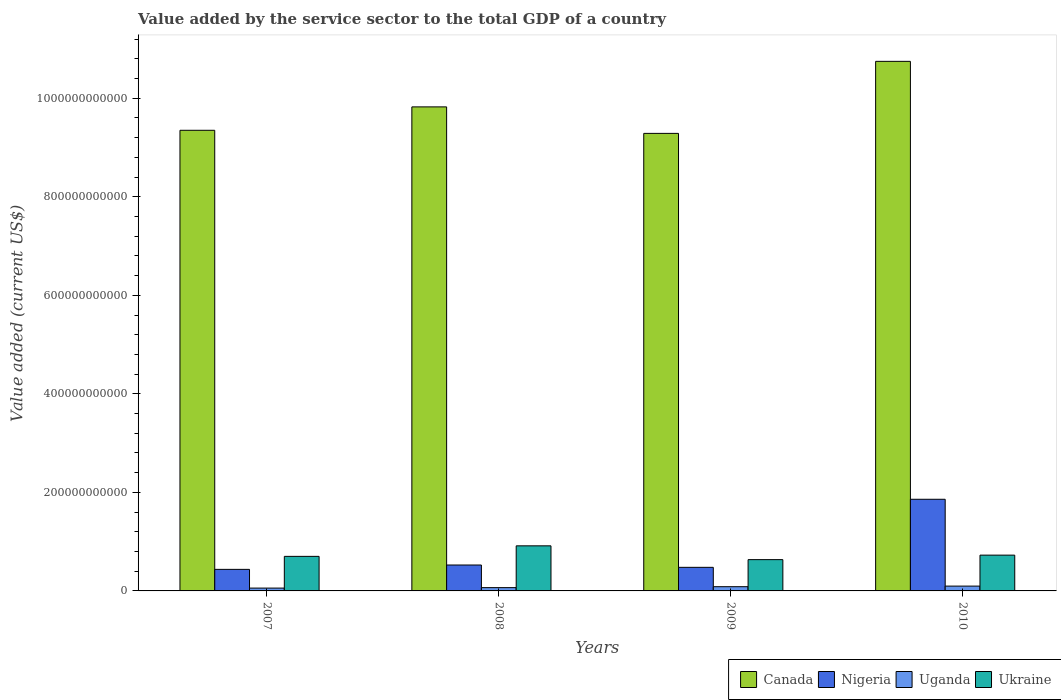What is the label of the 1st group of bars from the left?
Make the answer very short. 2007. What is the value added by the service sector to the total GDP in Ukraine in 2010?
Give a very brief answer. 7.26e+1. Across all years, what is the maximum value added by the service sector to the total GDP in Nigeria?
Offer a very short reply. 1.86e+11. Across all years, what is the minimum value added by the service sector to the total GDP in Ukraine?
Your response must be concise. 6.35e+1. In which year was the value added by the service sector to the total GDP in Ukraine maximum?
Your answer should be compact. 2008. In which year was the value added by the service sector to the total GDP in Ukraine minimum?
Keep it short and to the point. 2009. What is the total value added by the service sector to the total GDP in Uganda in the graph?
Your response must be concise. 3.08e+1. What is the difference between the value added by the service sector to the total GDP in Canada in 2007 and that in 2010?
Keep it short and to the point. -1.40e+11. What is the difference between the value added by the service sector to the total GDP in Ukraine in 2010 and the value added by the service sector to the total GDP in Uganda in 2009?
Your answer should be very brief. 6.41e+1. What is the average value added by the service sector to the total GDP in Canada per year?
Ensure brevity in your answer.  9.80e+11. In the year 2008, what is the difference between the value added by the service sector to the total GDP in Canada and value added by the service sector to the total GDP in Ukraine?
Offer a terse response. 8.91e+11. In how many years, is the value added by the service sector to the total GDP in Uganda greater than 440000000000 US$?
Offer a very short reply. 0. What is the ratio of the value added by the service sector to the total GDP in Uganda in 2007 to that in 2010?
Give a very brief answer. 0.59. Is the value added by the service sector to the total GDP in Ukraine in 2008 less than that in 2010?
Your answer should be very brief. No. Is the difference between the value added by the service sector to the total GDP in Canada in 2008 and 2009 greater than the difference between the value added by the service sector to the total GDP in Ukraine in 2008 and 2009?
Your response must be concise. Yes. What is the difference between the highest and the second highest value added by the service sector to the total GDP in Ukraine?
Offer a very short reply. 1.89e+1. What is the difference between the highest and the lowest value added by the service sector to the total GDP in Canada?
Your response must be concise. 1.46e+11. Is the sum of the value added by the service sector to the total GDP in Nigeria in 2007 and 2009 greater than the maximum value added by the service sector to the total GDP in Ukraine across all years?
Provide a succinct answer. Yes. Is it the case that in every year, the sum of the value added by the service sector to the total GDP in Nigeria and value added by the service sector to the total GDP in Canada is greater than the sum of value added by the service sector to the total GDP in Uganda and value added by the service sector to the total GDP in Ukraine?
Your answer should be compact. Yes. What does the 2nd bar from the left in 2010 represents?
Ensure brevity in your answer.  Nigeria. What does the 1st bar from the right in 2007 represents?
Make the answer very short. Ukraine. Is it the case that in every year, the sum of the value added by the service sector to the total GDP in Canada and value added by the service sector to the total GDP in Uganda is greater than the value added by the service sector to the total GDP in Nigeria?
Your answer should be compact. Yes. How many years are there in the graph?
Keep it short and to the point. 4. What is the difference between two consecutive major ticks on the Y-axis?
Provide a short and direct response. 2.00e+11. Does the graph contain any zero values?
Provide a short and direct response. No. Does the graph contain grids?
Your answer should be very brief. No. Where does the legend appear in the graph?
Give a very brief answer. Bottom right. What is the title of the graph?
Your answer should be compact. Value added by the service sector to the total GDP of a country. What is the label or title of the Y-axis?
Your response must be concise. Value added (current US$). What is the Value added (current US$) in Canada in 2007?
Give a very brief answer. 9.35e+11. What is the Value added (current US$) of Nigeria in 2007?
Your response must be concise. 4.37e+1. What is the Value added (current US$) in Uganda in 2007?
Offer a very short reply. 5.77e+09. What is the Value added (current US$) in Ukraine in 2007?
Keep it short and to the point. 7.01e+1. What is the Value added (current US$) of Canada in 2008?
Offer a very short reply. 9.82e+11. What is the Value added (current US$) in Nigeria in 2008?
Your answer should be compact. 5.26e+1. What is the Value added (current US$) in Uganda in 2008?
Ensure brevity in your answer.  6.68e+09. What is the Value added (current US$) of Ukraine in 2008?
Your answer should be compact. 9.15e+1. What is the Value added (current US$) in Canada in 2009?
Offer a very short reply. 9.29e+11. What is the Value added (current US$) in Nigeria in 2009?
Offer a very short reply. 4.79e+1. What is the Value added (current US$) in Uganda in 2009?
Your answer should be very brief. 8.58e+09. What is the Value added (current US$) of Ukraine in 2009?
Your answer should be very brief. 6.35e+1. What is the Value added (current US$) of Canada in 2010?
Your answer should be very brief. 1.07e+12. What is the Value added (current US$) in Nigeria in 2010?
Your answer should be compact. 1.86e+11. What is the Value added (current US$) of Uganda in 2010?
Your response must be concise. 9.79e+09. What is the Value added (current US$) of Ukraine in 2010?
Offer a very short reply. 7.26e+1. Across all years, what is the maximum Value added (current US$) in Canada?
Your response must be concise. 1.07e+12. Across all years, what is the maximum Value added (current US$) of Nigeria?
Your answer should be very brief. 1.86e+11. Across all years, what is the maximum Value added (current US$) in Uganda?
Offer a terse response. 9.79e+09. Across all years, what is the maximum Value added (current US$) in Ukraine?
Make the answer very short. 9.15e+1. Across all years, what is the minimum Value added (current US$) in Canada?
Keep it short and to the point. 9.29e+11. Across all years, what is the minimum Value added (current US$) in Nigeria?
Offer a very short reply. 4.37e+1. Across all years, what is the minimum Value added (current US$) of Uganda?
Offer a terse response. 5.77e+09. Across all years, what is the minimum Value added (current US$) of Ukraine?
Give a very brief answer. 6.35e+1. What is the total Value added (current US$) in Canada in the graph?
Provide a succinct answer. 3.92e+12. What is the total Value added (current US$) of Nigeria in the graph?
Provide a short and direct response. 3.30e+11. What is the total Value added (current US$) in Uganda in the graph?
Offer a very short reply. 3.08e+1. What is the total Value added (current US$) in Ukraine in the graph?
Your answer should be very brief. 2.98e+11. What is the difference between the Value added (current US$) of Canada in 2007 and that in 2008?
Provide a succinct answer. -4.75e+1. What is the difference between the Value added (current US$) of Nigeria in 2007 and that in 2008?
Provide a short and direct response. -8.87e+09. What is the difference between the Value added (current US$) of Uganda in 2007 and that in 2008?
Offer a terse response. -9.09e+08. What is the difference between the Value added (current US$) of Ukraine in 2007 and that in 2008?
Your answer should be very brief. -2.14e+1. What is the difference between the Value added (current US$) in Canada in 2007 and that in 2009?
Make the answer very short. 6.28e+09. What is the difference between the Value added (current US$) in Nigeria in 2007 and that in 2009?
Your response must be concise. -4.13e+09. What is the difference between the Value added (current US$) of Uganda in 2007 and that in 2009?
Offer a terse response. -2.82e+09. What is the difference between the Value added (current US$) in Ukraine in 2007 and that in 2009?
Provide a succinct answer. 6.63e+09. What is the difference between the Value added (current US$) in Canada in 2007 and that in 2010?
Make the answer very short. -1.40e+11. What is the difference between the Value added (current US$) in Nigeria in 2007 and that in 2010?
Ensure brevity in your answer.  -1.42e+11. What is the difference between the Value added (current US$) of Uganda in 2007 and that in 2010?
Offer a very short reply. -4.02e+09. What is the difference between the Value added (current US$) in Ukraine in 2007 and that in 2010?
Give a very brief answer. -2.49e+09. What is the difference between the Value added (current US$) in Canada in 2008 and that in 2009?
Make the answer very short. 5.38e+1. What is the difference between the Value added (current US$) in Nigeria in 2008 and that in 2009?
Ensure brevity in your answer.  4.74e+09. What is the difference between the Value added (current US$) in Uganda in 2008 and that in 2009?
Offer a very short reply. -1.91e+09. What is the difference between the Value added (current US$) of Ukraine in 2008 and that in 2009?
Your response must be concise. 2.80e+1. What is the difference between the Value added (current US$) in Canada in 2008 and that in 2010?
Provide a short and direct response. -9.24e+1. What is the difference between the Value added (current US$) of Nigeria in 2008 and that in 2010?
Provide a short and direct response. -1.33e+11. What is the difference between the Value added (current US$) in Uganda in 2008 and that in 2010?
Give a very brief answer. -3.11e+09. What is the difference between the Value added (current US$) of Ukraine in 2008 and that in 2010?
Keep it short and to the point. 1.89e+1. What is the difference between the Value added (current US$) in Canada in 2009 and that in 2010?
Give a very brief answer. -1.46e+11. What is the difference between the Value added (current US$) of Nigeria in 2009 and that in 2010?
Provide a short and direct response. -1.38e+11. What is the difference between the Value added (current US$) of Uganda in 2009 and that in 2010?
Offer a terse response. -1.20e+09. What is the difference between the Value added (current US$) in Ukraine in 2009 and that in 2010?
Provide a succinct answer. -9.12e+09. What is the difference between the Value added (current US$) in Canada in 2007 and the Value added (current US$) in Nigeria in 2008?
Your answer should be very brief. 8.82e+11. What is the difference between the Value added (current US$) in Canada in 2007 and the Value added (current US$) in Uganda in 2008?
Your answer should be very brief. 9.28e+11. What is the difference between the Value added (current US$) in Canada in 2007 and the Value added (current US$) in Ukraine in 2008?
Your answer should be compact. 8.43e+11. What is the difference between the Value added (current US$) in Nigeria in 2007 and the Value added (current US$) in Uganda in 2008?
Offer a terse response. 3.71e+1. What is the difference between the Value added (current US$) in Nigeria in 2007 and the Value added (current US$) in Ukraine in 2008?
Keep it short and to the point. -4.78e+1. What is the difference between the Value added (current US$) of Uganda in 2007 and the Value added (current US$) of Ukraine in 2008?
Offer a terse response. -8.57e+1. What is the difference between the Value added (current US$) of Canada in 2007 and the Value added (current US$) of Nigeria in 2009?
Provide a short and direct response. 8.87e+11. What is the difference between the Value added (current US$) of Canada in 2007 and the Value added (current US$) of Uganda in 2009?
Your answer should be very brief. 9.26e+11. What is the difference between the Value added (current US$) of Canada in 2007 and the Value added (current US$) of Ukraine in 2009?
Offer a very short reply. 8.71e+11. What is the difference between the Value added (current US$) in Nigeria in 2007 and the Value added (current US$) in Uganda in 2009?
Ensure brevity in your answer.  3.51e+1. What is the difference between the Value added (current US$) of Nigeria in 2007 and the Value added (current US$) of Ukraine in 2009?
Ensure brevity in your answer.  -1.98e+1. What is the difference between the Value added (current US$) in Uganda in 2007 and the Value added (current US$) in Ukraine in 2009?
Provide a short and direct response. -5.77e+1. What is the difference between the Value added (current US$) of Canada in 2007 and the Value added (current US$) of Nigeria in 2010?
Your response must be concise. 7.49e+11. What is the difference between the Value added (current US$) in Canada in 2007 and the Value added (current US$) in Uganda in 2010?
Offer a terse response. 9.25e+11. What is the difference between the Value added (current US$) in Canada in 2007 and the Value added (current US$) in Ukraine in 2010?
Give a very brief answer. 8.62e+11. What is the difference between the Value added (current US$) in Nigeria in 2007 and the Value added (current US$) in Uganda in 2010?
Offer a terse response. 3.39e+1. What is the difference between the Value added (current US$) of Nigeria in 2007 and the Value added (current US$) of Ukraine in 2010?
Make the answer very short. -2.89e+1. What is the difference between the Value added (current US$) of Uganda in 2007 and the Value added (current US$) of Ukraine in 2010?
Give a very brief answer. -6.69e+1. What is the difference between the Value added (current US$) in Canada in 2008 and the Value added (current US$) in Nigeria in 2009?
Make the answer very short. 9.35e+11. What is the difference between the Value added (current US$) in Canada in 2008 and the Value added (current US$) in Uganda in 2009?
Your response must be concise. 9.74e+11. What is the difference between the Value added (current US$) of Canada in 2008 and the Value added (current US$) of Ukraine in 2009?
Offer a very short reply. 9.19e+11. What is the difference between the Value added (current US$) of Nigeria in 2008 and the Value added (current US$) of Uganda in 2009?
Provide a succinct answer. 4.40e+1. What is the difference between the Value added (current US$) of Nigeria in 2008 and the Value added (current US$) of Ukraine in 2009?
Make the answer very short. -1.09e+1. What is the difference between the Value added (current US$) of Uganda in 2008 and the Value added (current US$) of Ukraine in 2009?
Your answer should be very brief. -5.68e+1. What is the difference between the Value added (current US$) of Canada in 2008 and the Value added (current US$) of Nigeria in 2010?
Provide a succinct answer. 7.96e+11. What is the difference between the Value added (current US$) of Canada in 2008 and the Value added (current US$) of Uganda in 2010?
Provide a succinct answer. 9.73e+11. What is the difference between the Value added (current US$) in Canada in 2008 and the Value added (current US$) in Ukraine in 2010?
Your answer should be compact. 9.10e+11. What is the difference between the Value added (current US$) in Nigeria in 2008 and the Value added (current US$) in Uganda in 2010?
Provide a short and direct response. 4.28e+1. What is the difference between the Value added (current US$) in Nigeria in 2008 and the Value added (current US$) in Ukraine in 2010?
Offer a terse response. -2.00e+1. What is the difference between the Value added (current US$) in Uganda in 2008 and the Value added (current US$) in Ukraine in 2010?
Your answer should be very brief. -6.60e+1. What is the difference between the Value added (current US$) in Canada in 2009 and the Value added (current US$) in Nigeria in 2010?
Ensure brevity in your answer.  7.43e+11. What is the difference between the Value added (current US$) of Canada in 2009 and the Value added (current US$) of Uganda in 2010?
Your answer should be very brief. 9.19e+11. What is the difference between the Value added (current US$) of Canada in 2009 and the Value added (current US$) of Ukraine in 2010?
Provide a short and direct response. 8.56e+11. What is the difference between the Value added (current US$) in Nigeria in 2009 and the Value added (current US$) in Uganda in 2010?
Your response must be concise. 3.81e+1. What is the difference between the Value added (current US$) of Nigeria in 2009 and the Value added (current US$) of Ukraine in 2010?
Offer a very short reply. -2.48e+1. What is the difference between the Value added (current US$) of Uganda in 2009 and the Value added (current US$) of Ukraine in 2010?
Your response must be concise. -6.41e+1. What is the average Value added (current US$) in Canada per year?
Offer a terse response. 9.80e+11. What is the average Value added (current US$) of Nigeria per year?
Offer a terse response. 8.26e+1. What is the average Value added (current US$) in Uganda per year?
Give a very brief answer. 7.70e+09. What is the average Value added (current US$) of Ukraine per year?
Your answer should be compact. 7.44e+1. In the year 2007, what is the difference between the Value added (current US$) in Canada and Value added (current US$) in Nigeria?
Make the answer very short. 8.91e+11. In the year 2007, what is the difference between the Value added (current US$) of Canada and Value added (current US$) of Uganda?
Provide a short and direct response. 9.29e+11. In the year 2007, what is the difference between the Value added (current US$) of Canada and Value added (current US$) of Ukraine?
Give a very brief answer. 8.65e+11. In the year 2007, what is the difference between the Value added (current US$) of Nigeria and Value added (current US$) of Uganda?
Give a very brief answer. 3.80e+1. In the year 2007, what is the difference between the Value added (current US$) in Nigeria and Value added (current US$) in Ukraine?
Your answer should be very brief. -2.64e+1. In the year 2007, what is the difference between the Value added (current US$) in Uganda and Value added (current US$) in Ukraine?
Make the answer very short. -6.44e+1. In the year 2008, what is the difference between the Value added (current US$) in Canada and Value added (current US$) in Nigeria?
Your answer should be very brief. 9.30e+11. In the year 2008, what is the difference between the Value added (current US$) in Canada and Value added (current US$) in Uganda?
Your response must be concise. 9.76e+11. In the year 2008, what is the difference between the Value added (current US$) in Canada and Value added (current US$) in Ukraine?
Give a very brief answer. 8.91e+11. In the year 2008, what is the difference between the Value added (current US$) in Nigeria and Value added (current US$) in Uganda?
Your response must be concise. 4.59e+1. In the year 2008, what is the difference between the Value added (current US$) in Nigeria and Value added (current US$) in Ukraine?
Keep it short and to the point. -3.89e+1. In the year 2008, what is the difference between the Value added (current US$) of Uganda and Value added (current US$) of Ukraine?
Offer a very short reply. -8.48e+1. In the year 2009, what is the difference between the Value added (current US$) of Canada and Value added (current US$) of Nigeria?
Keep it short and to the point. 8.81e+11. In the year 2009, what is the difference between the Value added (current US$) of Canada and Value added (current US$) of Uganda?
Offer a terse response. 9.20e+11. In the year 2009, what is the difference between the Value added (current US$) of Canada and Value added (current US$) of Ukraine?
Give a very brief answer. 8.65e+11. In the year 2009, what is the difference between the Value added (current US$) of Nigeria and Value added (current US$) of Uganda?
Make the answer very short. 3.93e+1. In the year 2009, what is the difference between the Value added (current US$) of Nigeria and Value added (current US$) of Ukraine?
Provide a short and direct response. -1.56e+1. In the year 2009, what is the difference between the Value added (current US$) of Uganda and Value added (current US$) of Ukraine?
Give a very brief answer. -5.49e+1. In the year 2010, what is the difference between the Value added (current US$) of Canada and Value added (current US$) of Nigeria?
Give a very brief answer. 8.89e+11. In the year 2010, what is the difference between the Value added (current US$) of Canada and Value added (current US$) of Uganda?
Ensure brevity in your answer.  1.07e+12. In the year 2010, what is the difference between the Value added (current US$) of Canada and Value added (current US$) of Ukraine?
Your response must be concise. 1.00e+12. In the year 2010, what is the difference between the Value added (current US$) in Nigeria and Value added (current US$) in Uganda?
Keep it short and to the point. 1.76e+11. In the year 2010, what is the difference between the Value added (current US$) in Nigeria and Value added (current US$) in Ukraine?
Provide a succinct answer. 1.13e+11. In the year 2010, what is the difference between the Value added (current US$) of Uganda and Value added (current US$) of Ukraine?
Provide a short and direct response. -6.28e+1. What is the ratio of the Value added (current US$) of Canada in 2007 to that in 2008?
Your response must be concise. 0.95. What is the ratio of the Value added (current US$) in Nigeria in 2007 to that in 2008?
Your answer should be compact. 0.83. What is the ratio of the Value added (current US$) in Uganda in 2007 to that in 2008?
Your answer should be very brief. 0.86. What is the ratio of the Value added (current US$) of Ukraine in 2007 to that in 2008?
Provide a short and direct response. 0.77. What is the ratio of the Value added (current US$) in Canada in 2007 to that in 2009?
Your answer should be very brief. 1.01. What is the ratio of the Value added (current US$) of Nigeria in 2007 to that in 2009?
Provide a succinct answer. 0.91. What is the ratio of the Value added (current US$) in Uganda in 2007 to that in 2009?
Your response must be concise. 0.67. What is the ratio of the Value added (current US$) in Ukraine in 2007 to that in 2009?
Provide a short and direct response. 1.1. What is the ratio of the Value added (current US$) of Canada in 2007 to that in 2010?
Give a very brief answer. 0.87. What is the ratio of the Value added (current US$) of Nigeria in 2007 to that in 2010?
Ensure brevity in your answer.  0.24. What is the ratio of the Value added (current US$) in Uganda in 2007 to that in 2010?
Provide a short and direct response. 0.59. What is the ratio of the Value added (current US$) of Ukraine in 2007 to that in 2010?
Give a very brief answer. 0.97. What is the ratio of the Value added (current US$) in Canada in 2008 to that in 2009?
Your answer should be compact. 1.06. What is the ratio of the Value added (current US$) of Nigeria in 2008 to that in 2009?
Your response must be concise. 1.1. What is the ratio of the Value added (current US$) of Uganda in 2008 to that in 2009?
Your answer should be compact. 0.78. What is the ratio of the Value added (current US$) in Ukraine in 2008 to that in 2009?
Your answer should be compact. 1.44. What is the ratio of the Value added (current US$) in Canada in 2008 to that in 2010?
Give a very brief answer. 0.91. What is the ratio of the Value added (current US$) of Nigeria in 2008 to that in 2010?
Ensure brevity in your answer.  0.28. What is the ratio of the Value added (current US$) in Uganda in 2008 to that in 2010?
Provide a succinct answer. 0.68. What is the ratio of the Value added (current US$) of Ukraine in 2008 to that in 2010?
Ensure brevity in your answer.  1.26. What is the ratio of the Value added (current US$) of Canada in 2009 to that in 2010?
Give a very brief answer. 0.86. What is the ratio of the Value added (current US$) of Nigeria in 2009 to that in 2010?
Give a very brief answer. 0.26. What is the ratio of the Value added (current US$) in Uganda in 2009 to that in 2010?
Offer a terse response. 0.88. What is the ratio of the Value added (current US$) of Ukraine in 2009 to that in 2010?
Make the answer very short. 0.87. What is the difference between the highest and the second highest Value added (current US$) in Canada?
Offer a very short reply. 9.24e+1. What is the difference between the highest and the second highest Value added (current US$) in Nigeria?
Provide a succinct answer. 1.33e+11. What is the difference between the highest and the second highest Value added (current US$) of Uganda?
Your response must be concise. 1.20e+09. What is the difference between the highest and the second highest Value added (current US$) in Ukraine?
Your answer should be very brief. 1.89e+1. What is the difference between the highest and the lowest Value added (current US$) in Canada?
Make the answer very short. 1.46e+11. What is the difference between the highest and the lowest Value added (current US$) in Nigeria?
Offer a very short reply. 1.42e+11. What is the difference between the highest and the lowest Value added (current US$) of Uganda?
Ensure brevity in your answer.  4.02e+09. What is the difference between the highest and the lowest Value added (current US$) in Ukraine?
Give a very brief answer. 2.80e+1. 